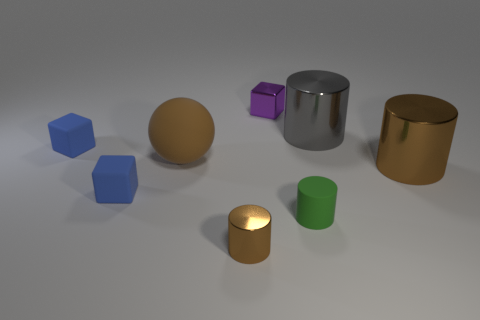Add 1 big shiny spheres. How many objects exist? 9 Subtract all cubes. How many objects are left? 5 Subtract 1 purple blocks. How many objects are left? 7 Subtract all blue cylinders. Subtract all green cylinders. How many objects are left? 7 Add 3 small cylinders. How many small cylinders are left? 5 Add 6 gray cylinders. How many gray cylinders exist? 7 